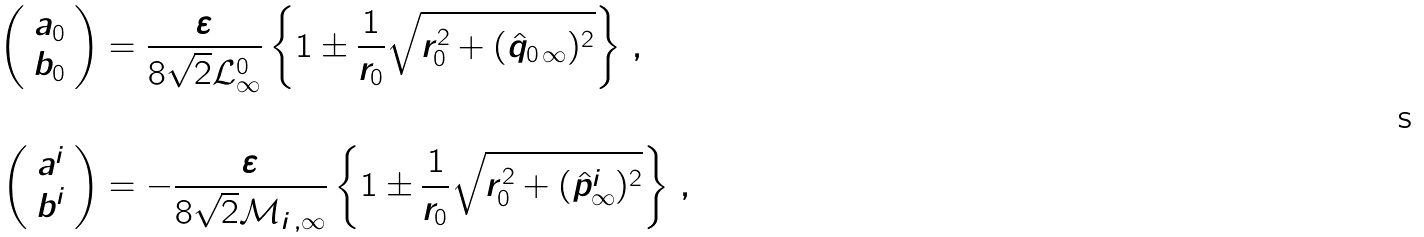Convert formula to latex. <formula><loc_0><loc_0><loc_500><loc_500>\left ( \begin{array} { c } a _ { 0 } \\ b _ { 0 } \\ \end{array} \right ) & = \frac { \varepsilon } { 8 \sqrt { 2 } \mathcal { L } ^ { 0 } _ { \infty } } \left \{ 1 \pm \frac { 1 } { r _ { 0 } } \sqrt { r _ { 0 } ^ { 2 } + ( \hat { q } _ { 0 \, \infty } ) ^ { 2 } } \right \} \, , \\ & \\ \left ( \begin{array} { c } a ^ { i } \\ b ^ { i } \\ \end{array} \right ) & = - \frac { \varepsilon } { 8 \sqrt { 2 } \mathcal { M } _ { i \, , \infty } } \left \{ 1 \pm \frac { 1 } { r _ { 0 } } \sqrt { r _ { 0 } ^ { 2 } + ( \hat { p } ^ { i } _ { \infty } ) ^ { 2 } } \right \} \, ,</formula> 